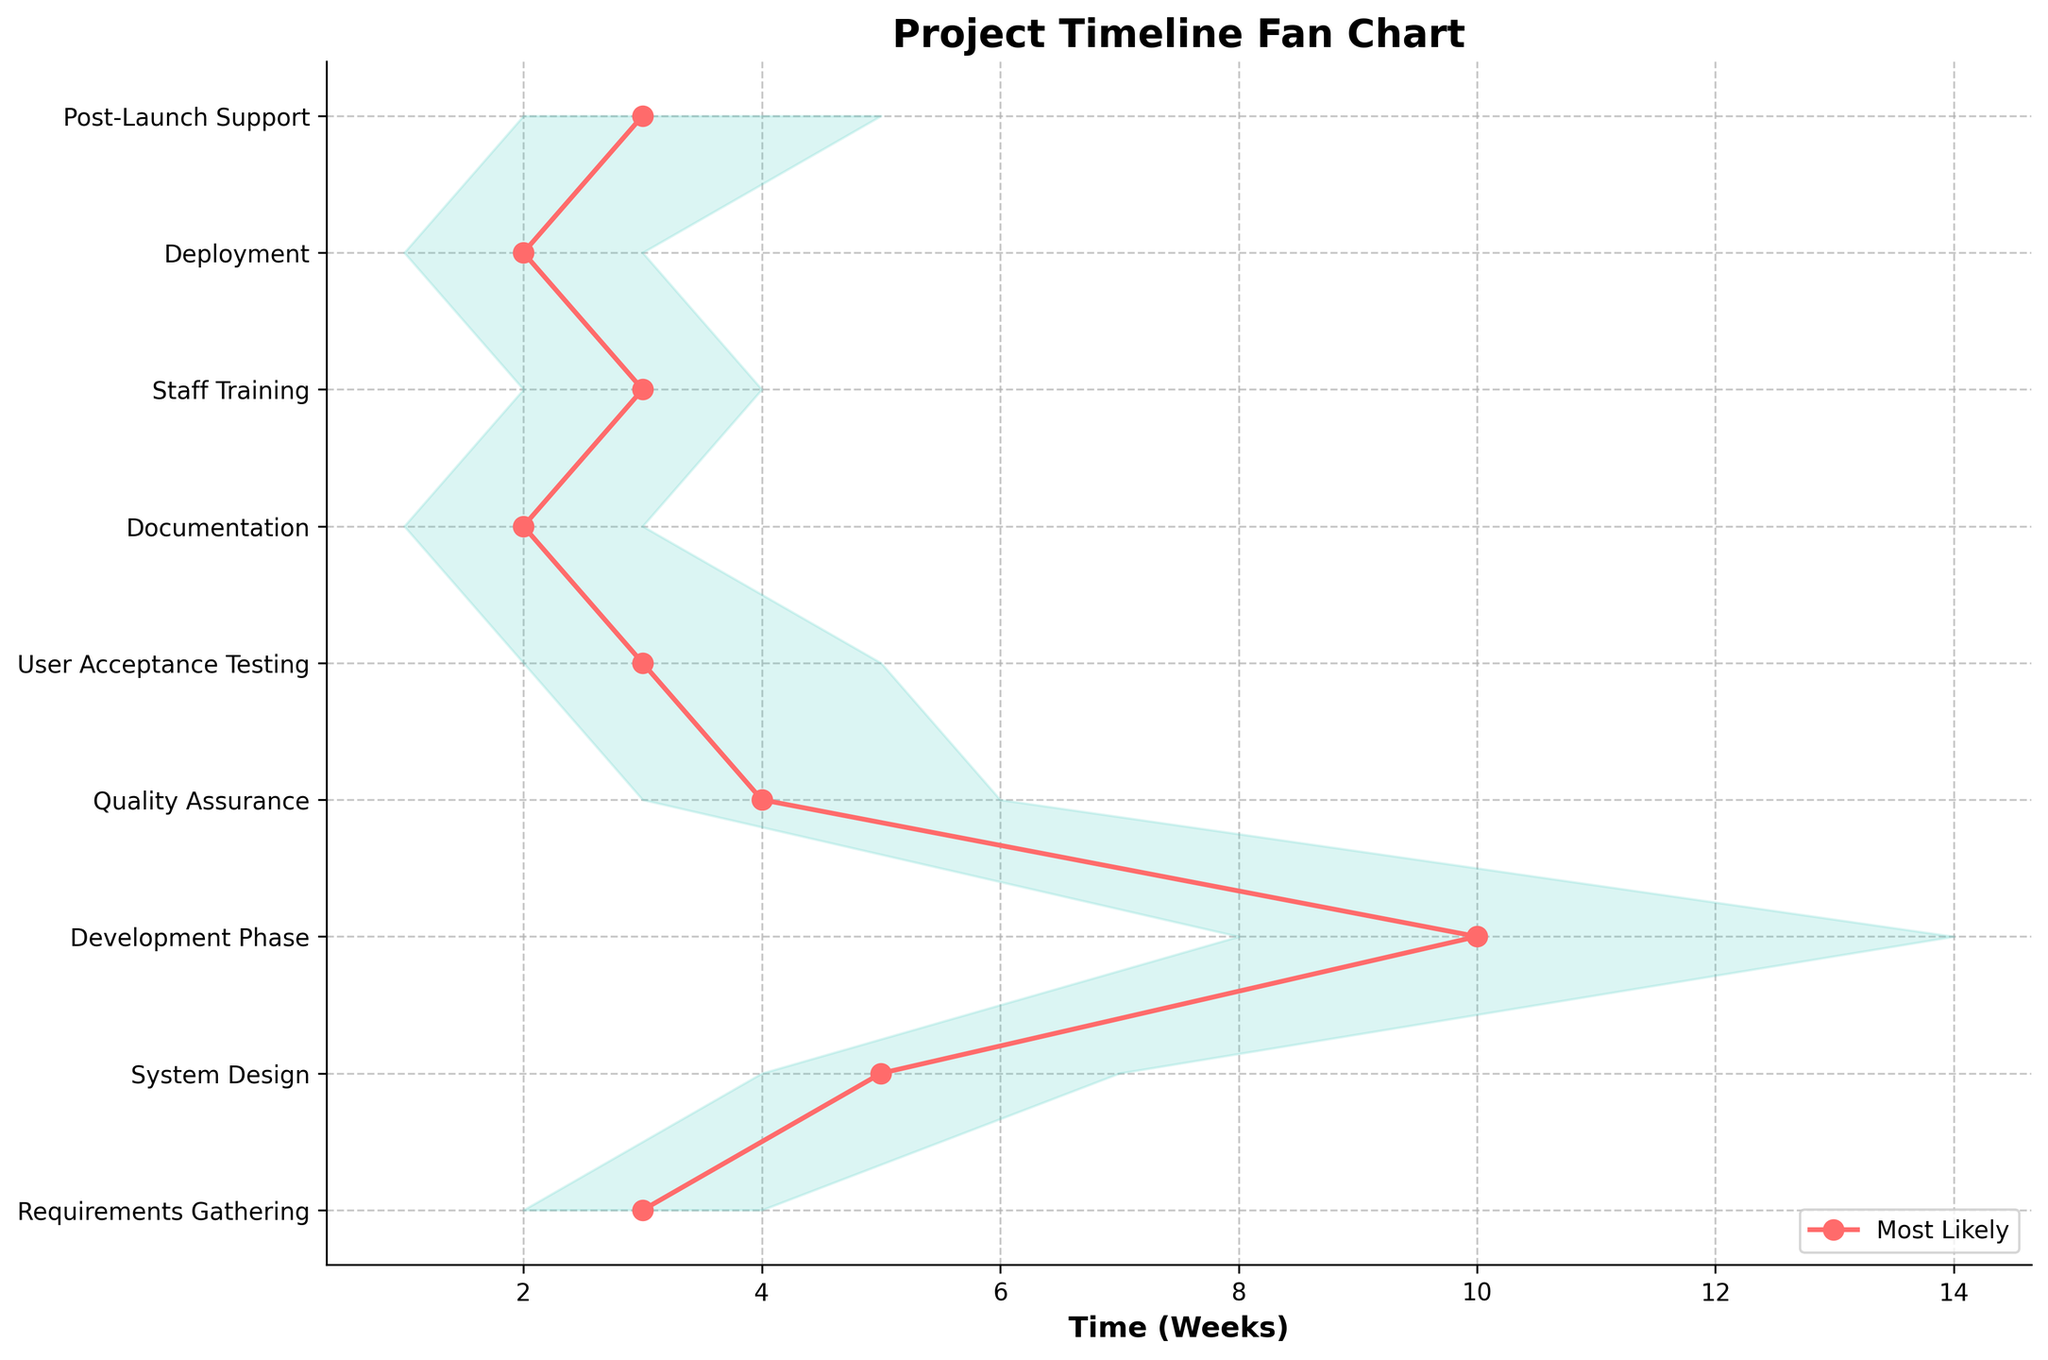What is the title of the figure? The title is usually found at the top of the figure and summarizes what the figure is about. By looking at the top, you will see it stated as "Project Timeline Fan Chart".
Answer: Project Timeline Fan Chart How many phases are included in the project timeline? The number of phases can be determined by counting the distinct labels on the Y-axis. Counting from top to bottom, we have Requirements Gathering, System Design, Development Phase, Quality Assurance, User Acceptance Testing, Documentation, Staff Training, Deployment, and Post-Launch Support, which totals nine phases.
Answer: 9 Which phase has the largest range between best-case and worst-case scenarios? To determine this, you need to look for the phase with the largest difference between best-case and worst-case values. The Development Phase has a range of 6 weeks (14 - 8), which is the largest among all phases.
Answer: Development Phase What is the shortest estimated time in the best-case scenario? To find this, look at all the best case values and find the minimum. The shortest time in the best-case scenario is 1 week, which is seen in both the Documentation and Deployment phases.
Answer: 1 week On which phase does the worst-case scenario time exceed the most likely time by the most? Calculate the difference between the worst-case and most likely times for each phase, and find the maximum difference. The Development Phase has the biggest excess, with a worst-case scenario of 14 weeks over the most likely 10 weeks, giving a difference of 4 weeks.
Answer: Development Phase What is the total time for the best-case scenarios of all phases combined? Sum up the best-case scenario values for each phase: 2 + 4 + 8 + 3 + 2 + 1 + 2 + 1 + 2 = 25 weeks.
Answer: 25 weeks Are there any phases where the most likely scenario is equal to the best-case scenario? Check each phase to see if the best-case and most likely values are the same. There are no such phases where these values are equal.
Answer: No What is the average worst-case scenario time across all phases? Sum the worst-case scenario values and divide by the number of phases. The total is 4 + 7 + 14 + 6 + 5 + 3 + 4 + 3 + 5 = 51 weeks, and there are 9 phases, so the average is 51 / 9 ≈ 5.67 weeks.
Answer: 5.67 weeks Which phase has the closest estimated times across all scenarios (best, most likely, worst)? Look for the phase with the smallest overall spread between best-case and worst-case times. Documentation phase has times of 1, 2, and 3 weeks respectively, giving a range of 2 weeks, which is the smallest spread.
Answer: Documentation Is the time for User Acceptance Testing in the most likely case longer or shorter than that for System Design in the best-case scenario? Compare the most likely time for User Acceptance Testing (3 weeks) with the best-case time for System Design (4 weeks). User Acceptance Testing is shorter.
Answer: Shorter 